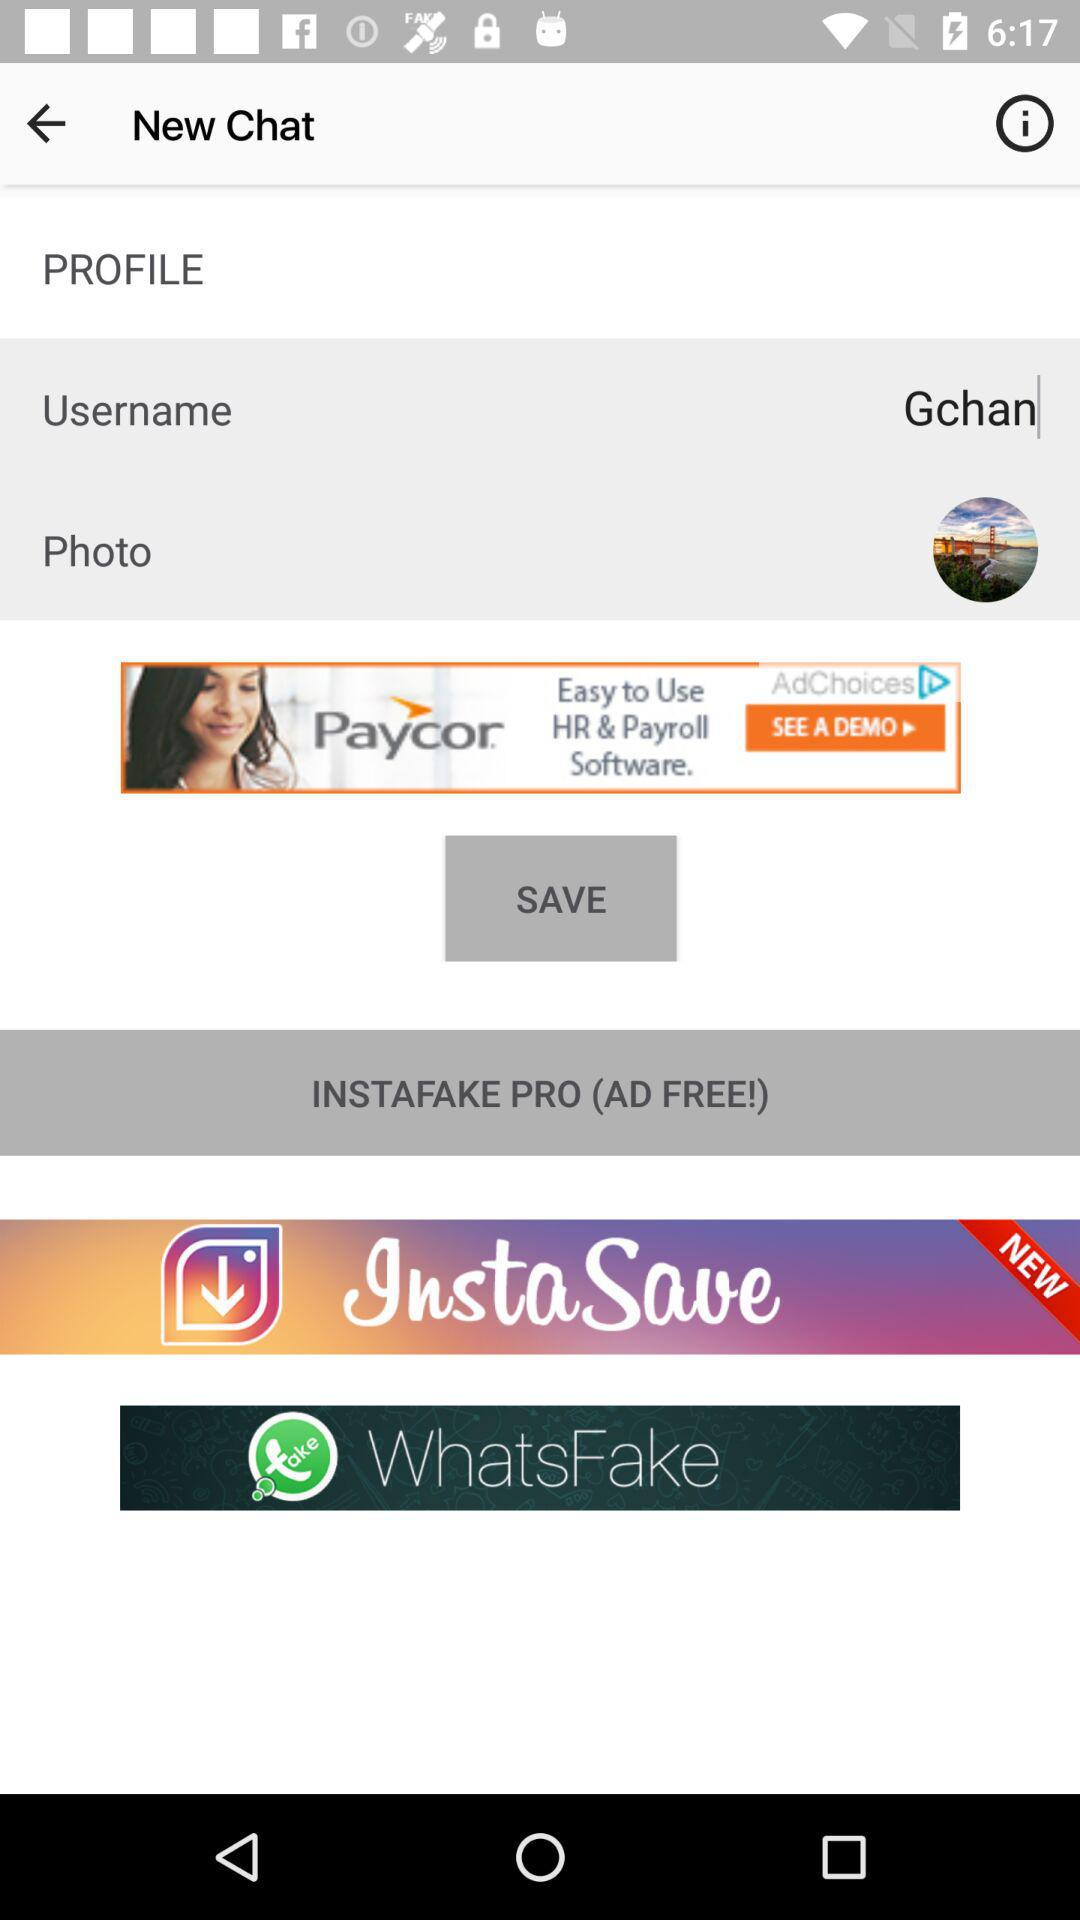What is the username? The username is "Gchan". 